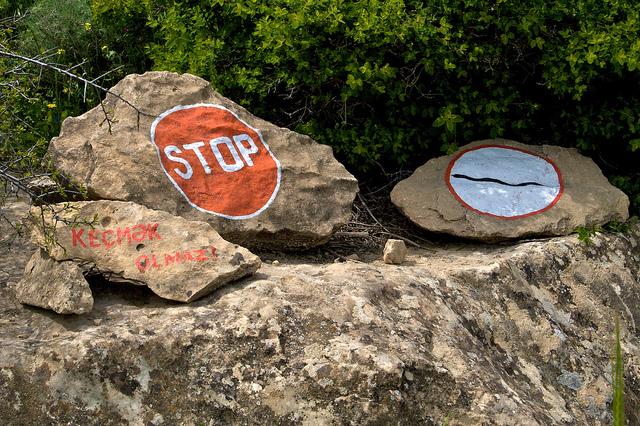What color is the lettering on the stop sign?
Keep it brief. White. Is this inside or outside?
Be succinct. Outside. Are the signs painted on the rocks?
Be succinct. Yes. 